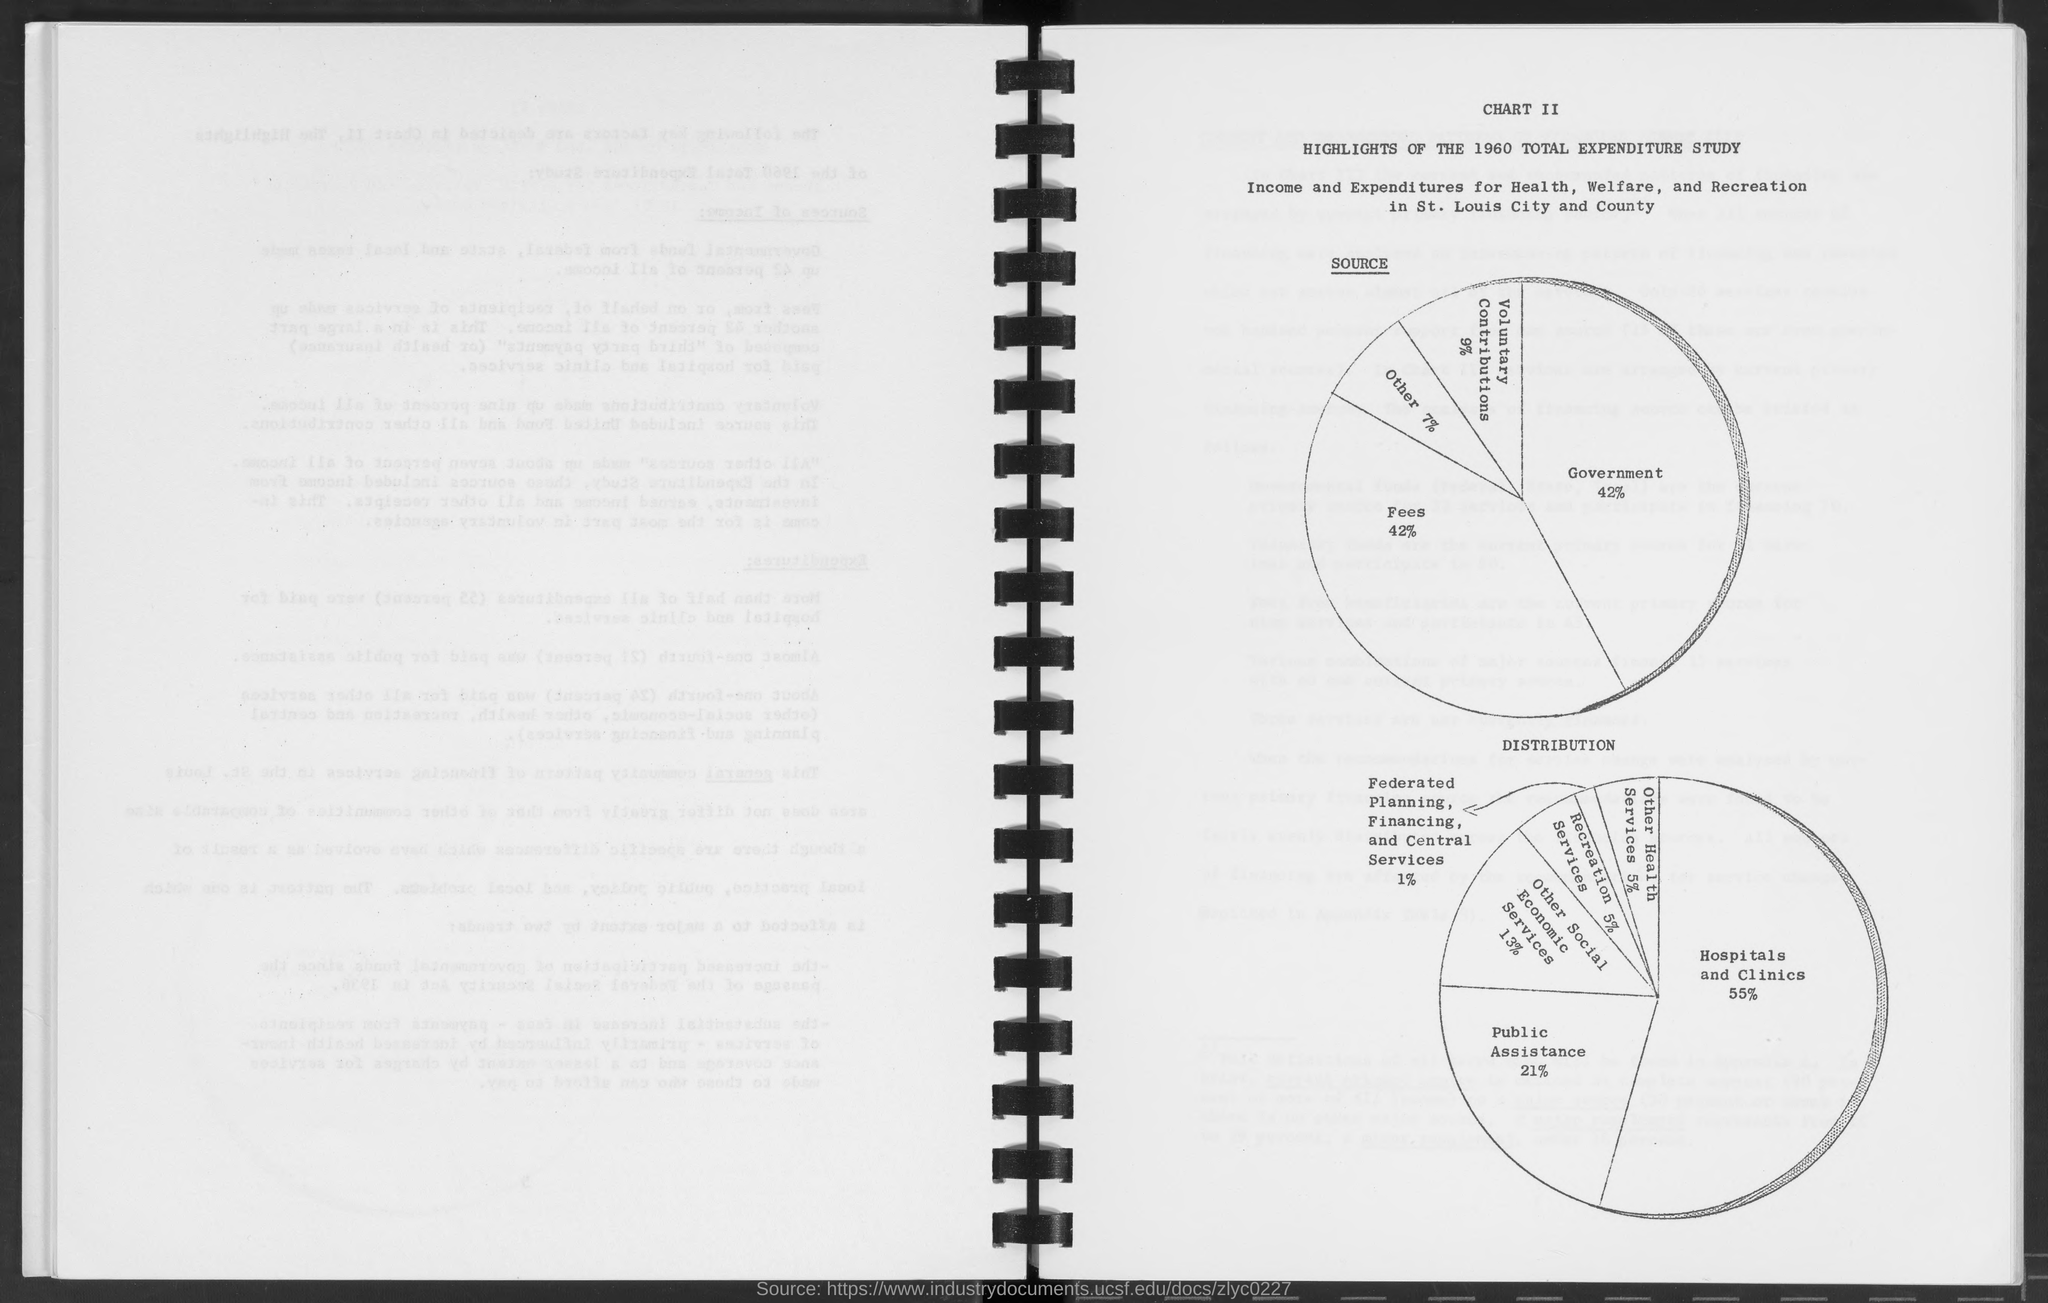What is the percentage for government in source as mentioned in the given page ?
Provide a succinct answer. 42%. What is the percentage for fees in source as mentioned in the given page ?
Provide a short and direct response. 42%. What is the percentage for others in source as mentioned in the given page ?
Give a very brief answer. 7%. What is the percentage for voluntary contributions in source as mentioned in the given page ?
Provide a succinct answer. 9%. What is the percentage for hospitals and clinics in distribution as mentioned in the given page ?
Make the answer very short. 55%. What is the percentage for public assistance in distribution as mentioned in the given page ?
Your response must be concise. 21%. What is the percentage for other health services in distribution as mentioned in the given page ?
Offer a terse response. 5%. What is the percentage for other social economic services in distribution as mentioned in the given page ?
Give a very brief answer. 13%. What is the percentage for recreation services in distribution as mentioned in the given page ?
Offer a very short reply. 5%. 